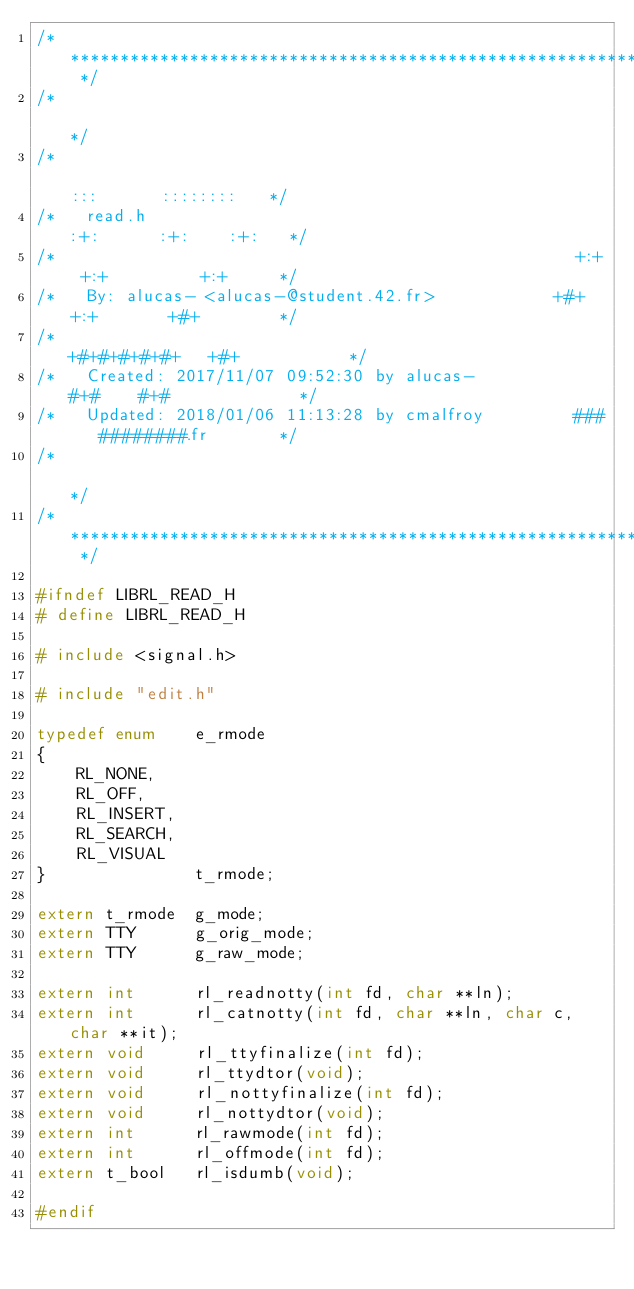Convert code to text. <code><loc_0><loc_0><loc_500><loc_500><_C_>/* ************************************************************************** */
/*                                                                            */
/*                                                        :::      ::::::::   */
/*   read.h                                             :+:      :+:    :+:   */
/*                                                    +:+ +:+         +:+     */
/*   By: alucas- <alucas-@student.42.fr>            +#+  +:+       +#+        */
/*                                                +#+#+#+#+#+   +#+           */
/*   Created: 2017/11/07 09:52:30 by alucas-           #+#    #+#             */
/*   Updated: 2018/01/06 11:13:28 by cmalfroy         ###   ########.fr       */
/*                                                                            */
/* ************************************************************************** */

#ifndef LIBRL_READ_H
# define LIBRL_READ_H

# include <signal.h>

# include "edit.h"

typedef enum	e_rmode
{
	RL_NONE,
	RL_OFF,
	RL_INSERT,
	RL_SEARCH,
	RL_VISUAL
}				t_rmode;

extern t_rmode	g_mode;
extern TTY		g_orig_mode;
extern TTY		g_raw_mode;

extern int		rl_readnotty(int fd, char **ln);
extern int		rl_catnotty(int fd, char **ln, char c, char **it);
extern void		rl_ttyfinalize(int fd);
extern void		rl_ttydtor(void);
extern void		rl_nottyfinalize(int fd);
extern void		rl_nottydtor(void);
extern int		rl_rawmode(int fd);
extern int		rl_offmode(int fd);
extern t_bool	rl_isdumb(void);

#endif
</code> 